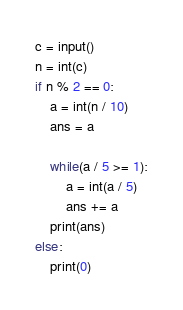Convert code to text. <code><loc_0><loc_0><loc_500><loc_500><_Python_>c = input()
n = int(c)
if n % 2 == 0:
	a = int(n / 10)
	ans = a
	
	while(a / 5 >= 1):
		a = int(a / 5)
		ans += a
	print(ans)
else:
	print(0)</code> 